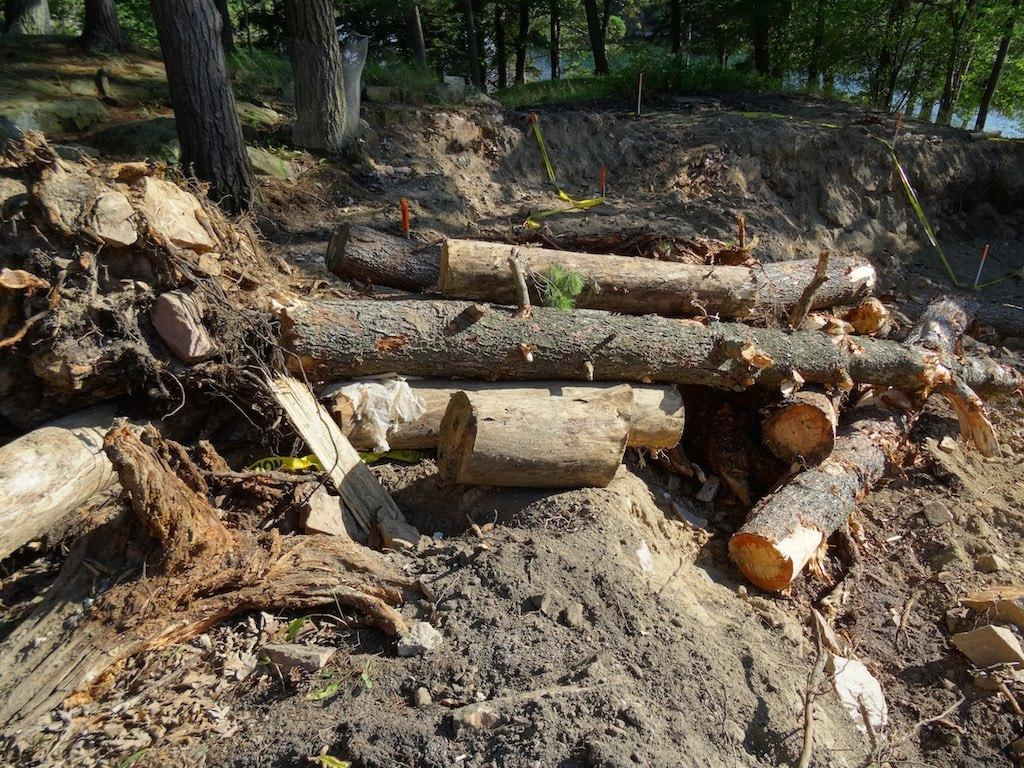What is on the ground in the image? There are logs on the ground in the image. What type of vegetation covers the ground in the image? The ground is covered with grass in the image. What other types of vegetation can be seen in the image? Plants and trees are present in the image. What type of board is being offered to the plants in the image? There is no board being offered to the plants in the image. 